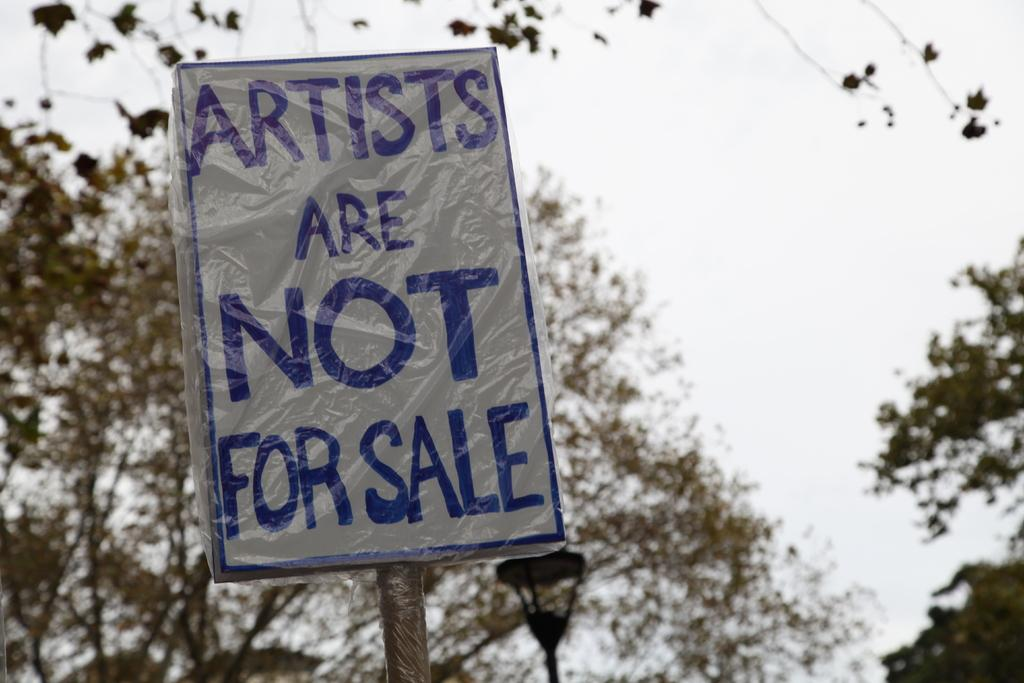What is the main object in the center of the image? There is a board in the center of the image. What can be seen in the background of the image? There are trees and the sky visible in the background of the image. What type of teeth can be seen on the board in the image? There are no teeth present on the board in the image. How is the hose used in the yard in the image? There is no hose or yard present in the image; it only features a board and trees in the background. 